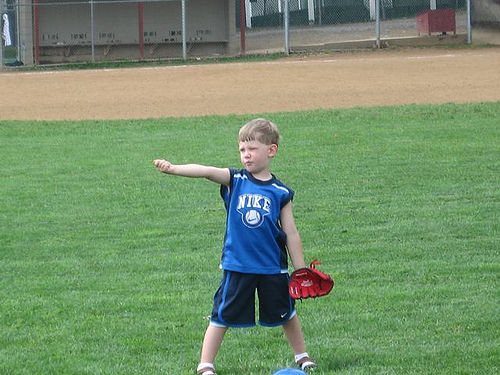Please provide the bounding box coordinate of the region this sentence describes: legs of the boy. The coordinates [0.33, 0.77, 0.66, 0.81] accurately outline the lower section of the boy's legs, visible below his blue shorts. 